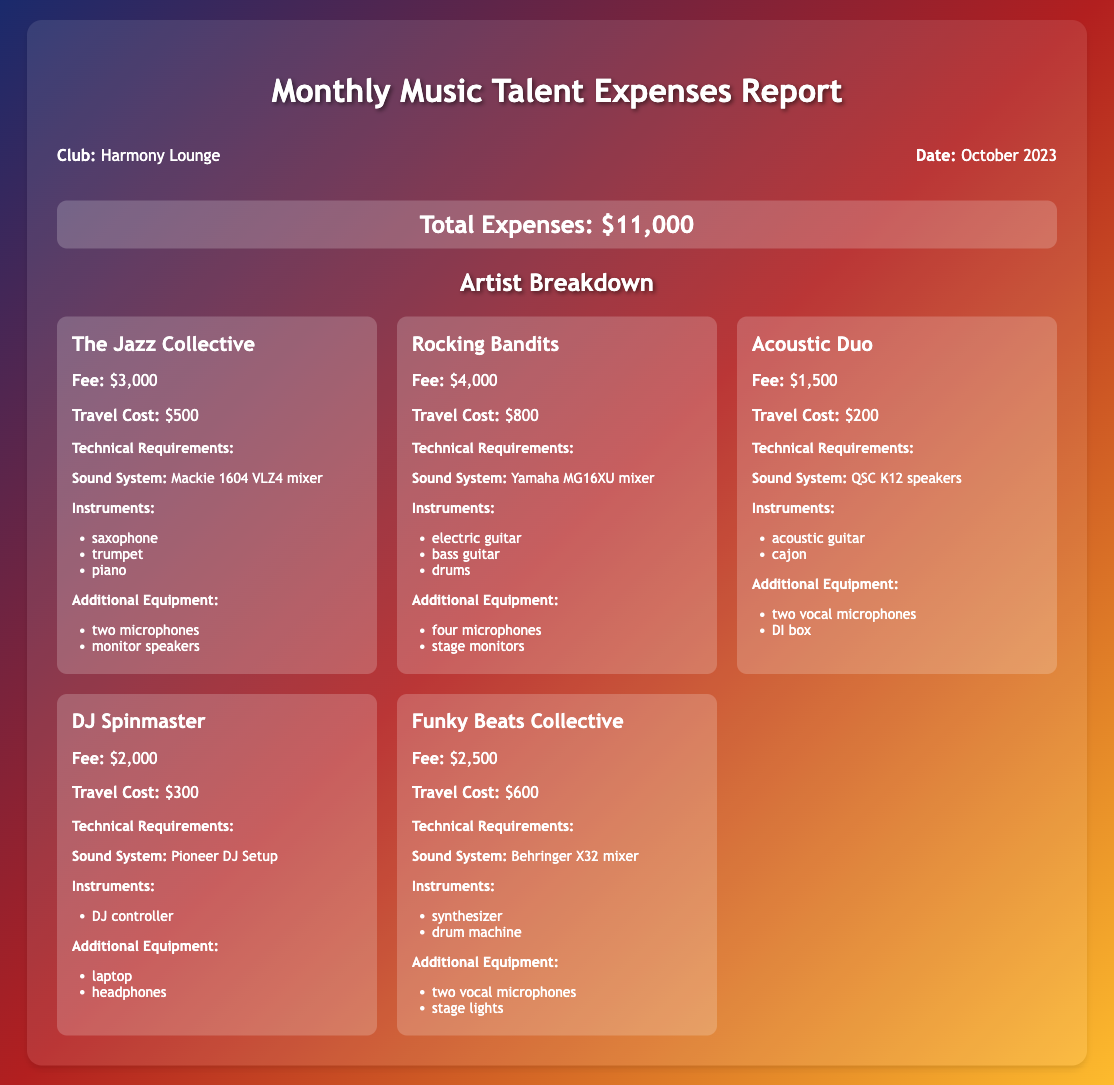what is the total expense for October 2023? The total expense is stated at the top of the report as $11,000.
Answer: $11,000 how much does The Jazz Collective charge? The fee for The Jazz Collective is listed as $3,000.
Answer: $3,000 what is the travel cost for Rocking Bandits? The travel cost for Rocking Bandits is provided as $800.
Answer: $800 what sound system is required by DJ Spinmaster? The report specifies that DJ Spinmaster requires a Pioneer DJ Setup as the sound system.
Answer: Pioneer DJ Setup how many instruments does Acoustic Duo require? The instruments listed for Acoustic Duo include an acoustic guitar and a cajon, totaling two instruments.
Answer: two which artist has the highest fee? The highest fee among the artists is attributed to Rocking Bandits, who charge $4,000.
Answer: Rocking Bandits what additional equipment is requested by Funky Beats Collective? Funky Beats Collective requests two vocal microphones and stage lights as additional equipment.
Answer: two vocal microphones and stage lights which technical requirement is common across all artists? The need for a sound system is a common requirement for all listed artists in the report.
Answer: sound system how many different technical requirements categories are mentioned in the document? The document lists technical requirements divided into sound systems, instruments, and additional equipment, indicating three categories.
Answer: three 